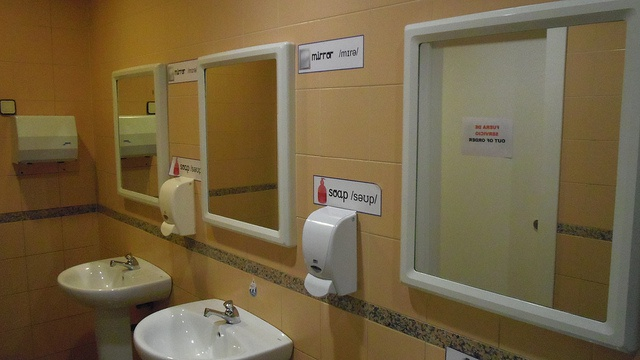Describe the objects in this image and their specific colors. I can see a sink in maroon, darkgray, and gray tones in this image. 